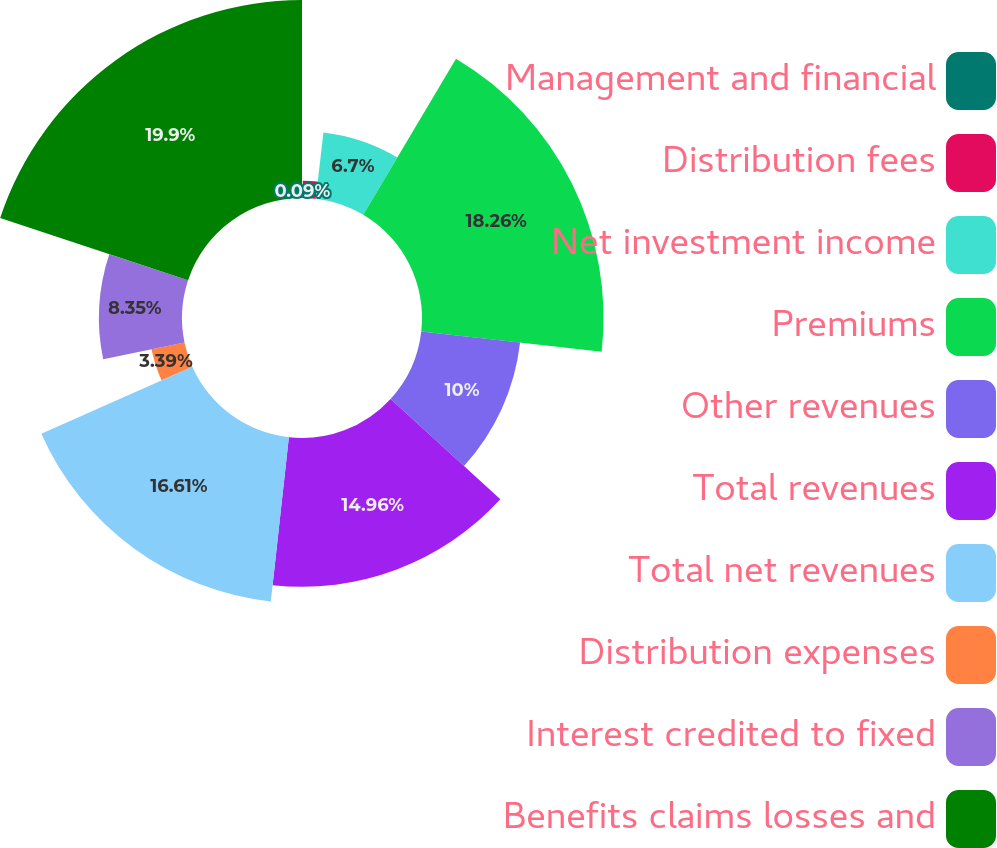<chart> <loc_0><loc_0><loc_500><loc_500><pie_chart><fcel>Management and financial<fcel>Distribution fees<fcel>Net investment income<fcel>Premiums<fcel>Other revenues<fcel>Total revenues<fcel>Total net revenues<fcel>Distribution expenses<fcel>Interest credited to fixed<fcel>Benefits claims losses and<nl><fcel>0.09%<fcel>1.74%<fcel>6.7%<fcel>18.26%<fcel>10.0%<fcel>14.96%<fcel>16.61%<fcel>3.39%<fcel>8.35%<fcel>19.91%<nl></chart> 